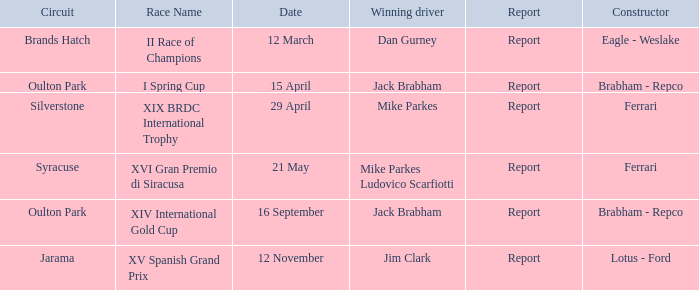What is the name of the race on 16 september? XIV International Gold Cup. 